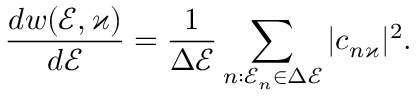<formula> <loc_0><loc_0><loc_500><loc_500>\frac { d w ( \mathcal { E } , \varkappa ) } { d \mathcal { E } } = \frac { 1 } { \Delta \mathcal { E } } \sum _ { n \colon \mathcal { E } _ { n } \in \Delta \mathcal { E } } | c _ { n \varkappa } | ^ { 2 } .</formula> 